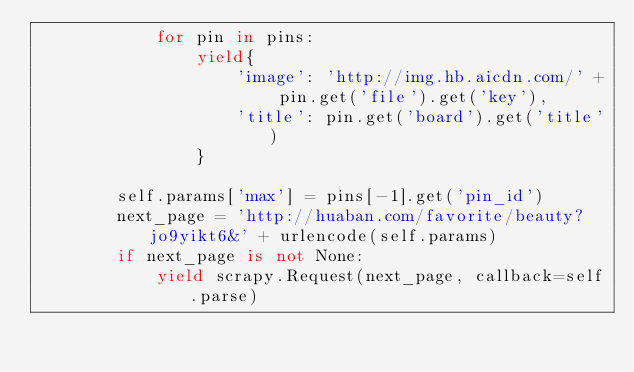<code> <loc_0><loc_0><loc_500><loc_500><_Python_>            for pin in pins:
                yield{
                    'image': 'http://img.hb.aicdn.com/' + pin.get('file').get('key'),
                    'title': pin.get('board').get('title')
                }

        self.params['max'] = pins[-1].get('pin_id')
        next_page = 'http://huaban.com/favorite/beauty?jo9yikt6&' + urlencode(self.params)
        if next_page is not None:
            yield scrapy.Request(next_page, callback=self.parse)</code> 